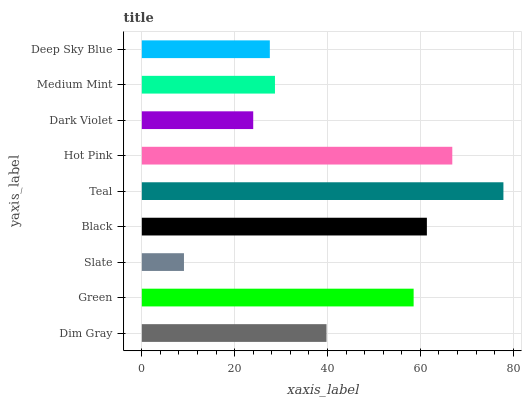Is Slate the minimum?
Answer yes or no. Yes. Is Teal the maximum?
Answer yes or no. Yes. Is Green the minimum?
Answer yes or no. No. Is Green the maximum?
Answer yes or no. No. Is Green greater than Dim Gray?
Answer yes or no. Yes. Is Dim Gray less than Green?
Answer yes or no. Yes. Is Dim Gray greater than Green?
Answer yes or no. No. Is Green less than Dim Gray?
Answer yes or no. No. Is Dim Gray the high median?
Answer yes or no. Yes. Is Dim Gray the low median?
Answer yes or no. Yes. Is Black the high median?
Answer yes or no. No. Is Deep Sky Blue the low median?
Answer yes or no. No. 